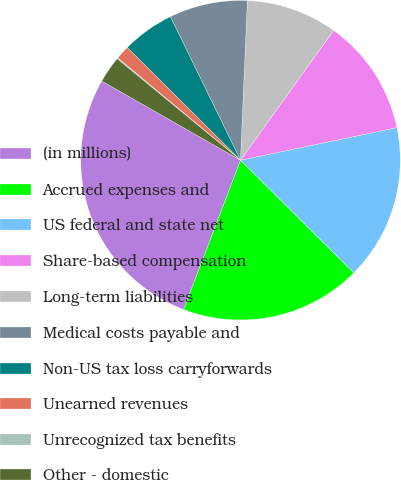Convert chart to OTSL. <chart><loc_0><loc_0><loc_500><loc_500><pie_chart><fcel>(in millions)<fcel>Accrued expenses and<fcel>US federal and state net<fcel>Share-based compensation<fcel>Long-term liabilities<fcel>Medical costs payable and<fcel>Non-US tax loss carryforwards<fcel>Unearned revenues<fcel>Unrecognized tax benefits<fcel>Other - domestic<nl><fcel>27.46%<fcel>18.34%<fcel>15.73%<fcel>11.82%<fcel>9.22%<fcel>7.92%<fcel>5.31%<fcel>1.4%<fcel>0.1%<fcel>2.7%<nl></chart> 